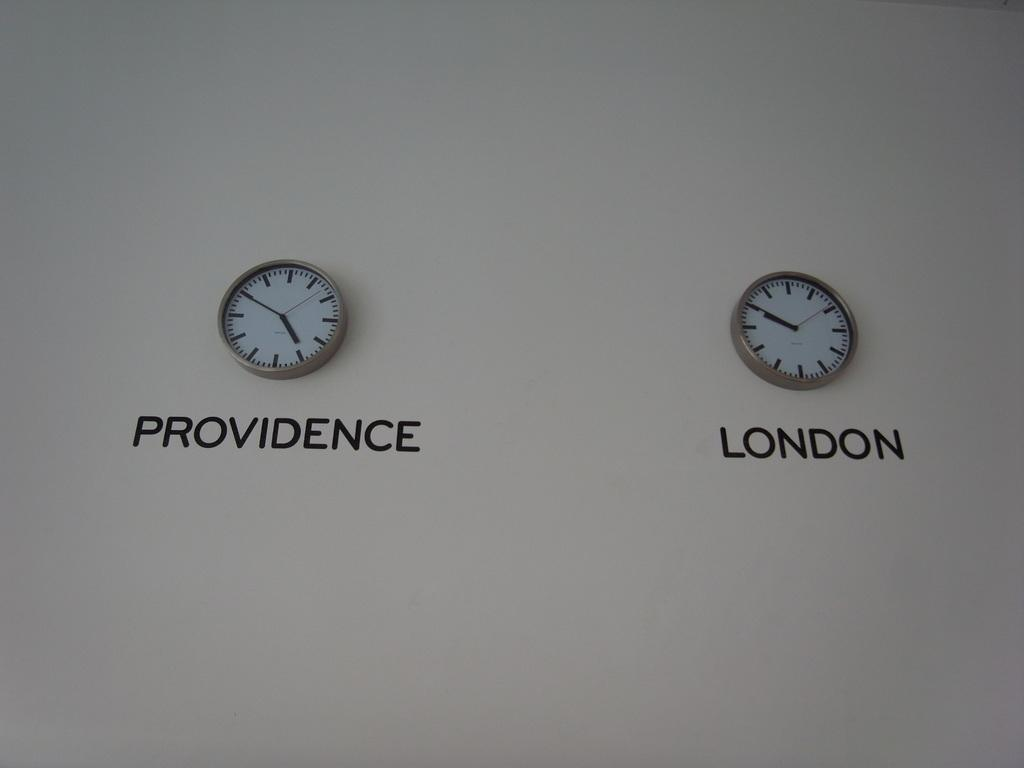<image>
Summarize the visual content of the image. Two similar clocks one from providencce and one from london 